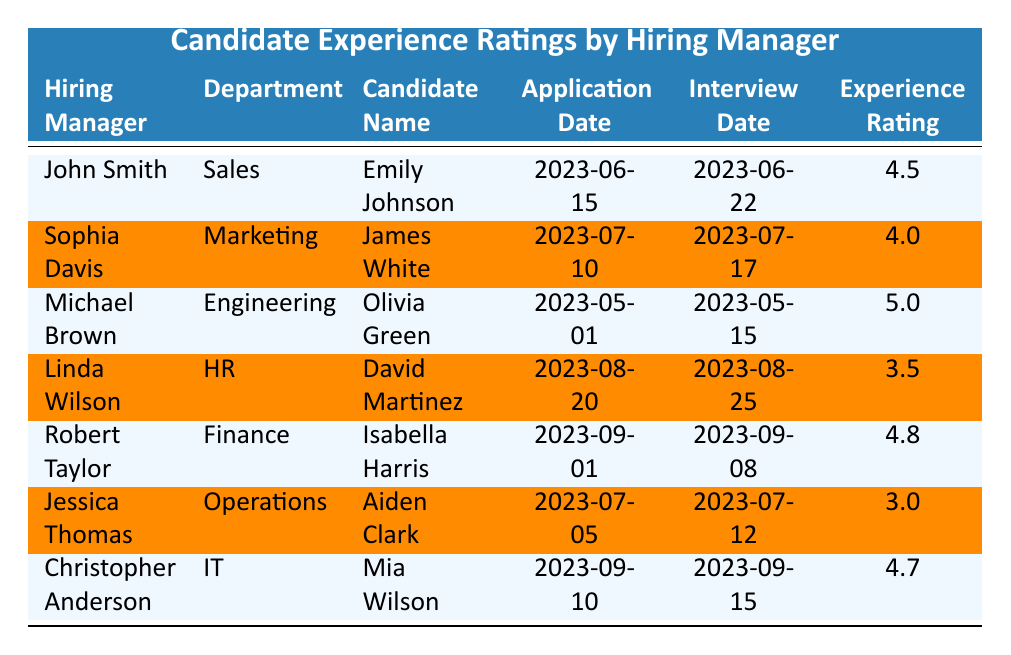What is the highest experience rating among the candidates? The highest experience rating in the table is identified by scanning through the "Experience Rating" column. Among the ratings, Olivia Green has the highest rating of 5.0.
Answer: 5.0 Who interviewed James White? By looking at the "Candidate Name" for James White, we can follow the same row to see that the hiring manager is Sophia Davis.
Answer: Sophia Davis What was the application date for Isabella Harris? The application date can be found in the row corresponding to Isabella Harris. The date listed is 2023-09-01.
Answer: 2023-09-01 How many candidates received an experience rating below 4.0? Counting the ratings below 4.0, Aiden Clark has a rating of 3.0 and David Martinez has a rating of 3.5, giving a total of 2 candidates.
Answer: 2 What is the average experience rating of all candidates? To find the average, sum all experience ratings: (4.5 + 4.0 + 5.0 + 3.5 + 4.8 + 3.0 + 4.7) = 29.5. Divide by the total number of candidates (7), which gives 29.5 / 7 = 4.21.
Answer: 4.21 Which hiring manager had the lowest rated candidate? By examining the experience ratings, Jessica Thomas had the lowest rating with Aiden Clark rated at 3.0.
Answer: Jessica Thomas Did any candidate interview after August 25, 2023? Checking the interview dates, we see that Mia Wilson interviewed on 2023-09-15, which is indeed after August 25, 2023.
Answer: Yes Which department had the candidate with the highest experience rating? The candidate with the highest rating is Olivia Green from the Engineering department, so that is the department that had the highest experience rating.
Answer: Engineering What was the experience rating difference between David Martinez and Isabella Harris? David Martinez has a rating of 3.5 and Isabella Harris has a rating of 4.8. The difference is calculated as 4.8 - 3.5 = 1.3.
Answer: 1.3 List all candidates who rated above 4.5. By scanning the experience rating column, Olivia Green (5.0) and Isabella Harris (4.8) are the only candidates above 4.5.
Answer: Olivia Green, Isabella Harris What fraction of candidates rated over 4.0? There are 4 candidates rated over 4.0 (Emily Johnson, Olivia Green, Isabella Harris, and Mia Wilson) out of a total of 7 candidates. Thus, the fraction is 4/7.
Answer: 4/7 